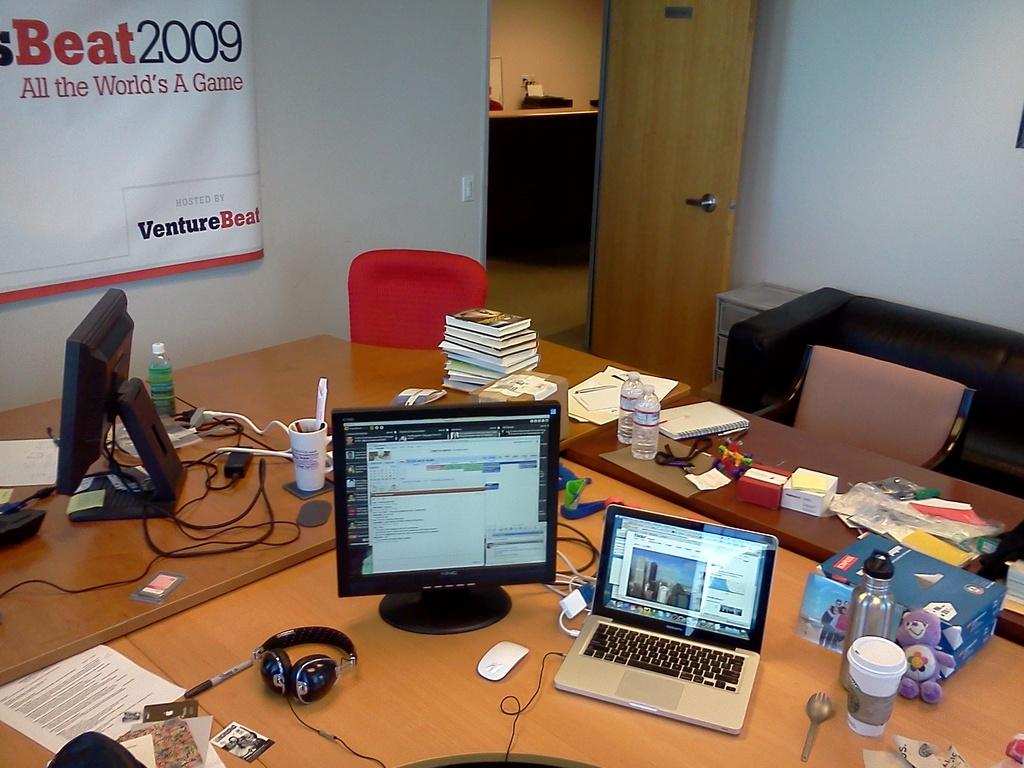What is the color of the wall in the image? The wall in the image is white. What can be found on the wall in the image? There is a door and a banner on the wall in the image. What type of furniture is present in the image? There is a sofa and a table in the image. What items can be seen on the table in the image? On the table, there are laptops, books, bottles, papers, toys, and glasses. What type of dress is hanging on the door in the image? There is no dress hanging on the door in the image; the door is part of the wall and has a banner on it. What angle is the sofa positioned at in the image? The angle of the sofa cannot be determined from the image, as it is a two-dimensional representation. 